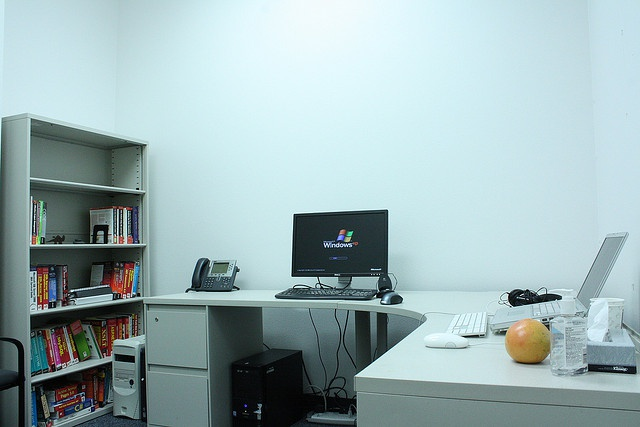Describe the objects in this image and their specific colors. I can see book in lightblue, black, maroon, gray, and blue tones, tv in lightblue, black, purple, and darkblue tones, laptop in lightblue, darkgray, and black tones, apple in lightblue, tan, and olive tones, and keyboard in lightblue and darkgray tones in this image. 